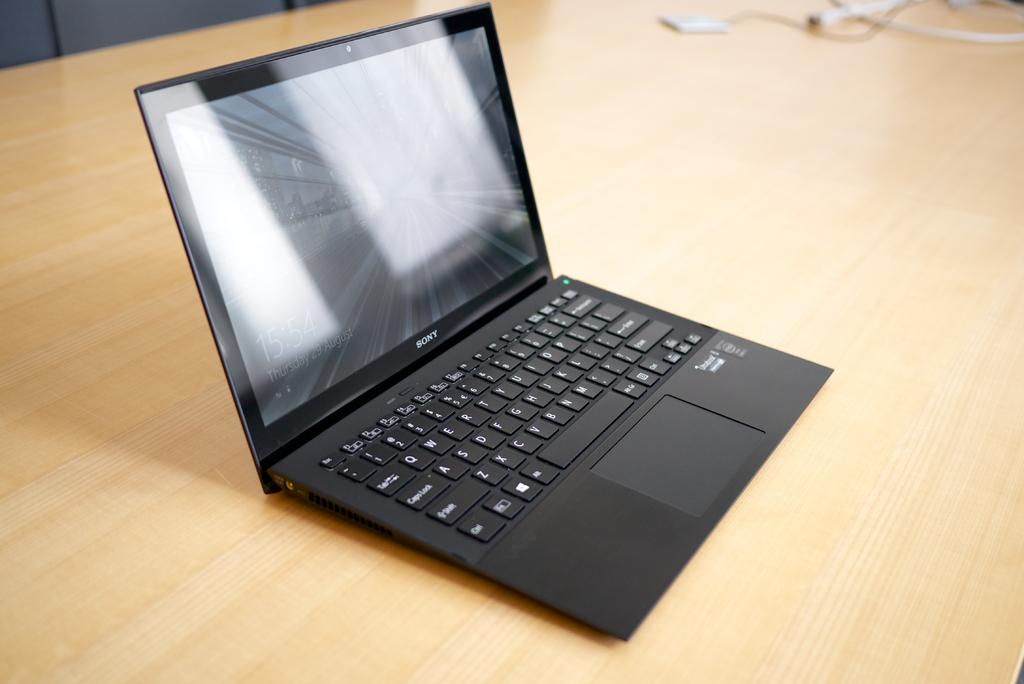What electronic device is visible in the image? There is a laptop in the image. Where is the laptop located? The laptop is placed on a table. What type of garden can be seen growing in the background of the image? There is no garden present in the image; it features a laptop placed on a table. What type of sea creature might be swimming in the bowl of oatmeal in the image? There is no bowl of oatmeal or sea creature present in the image. 